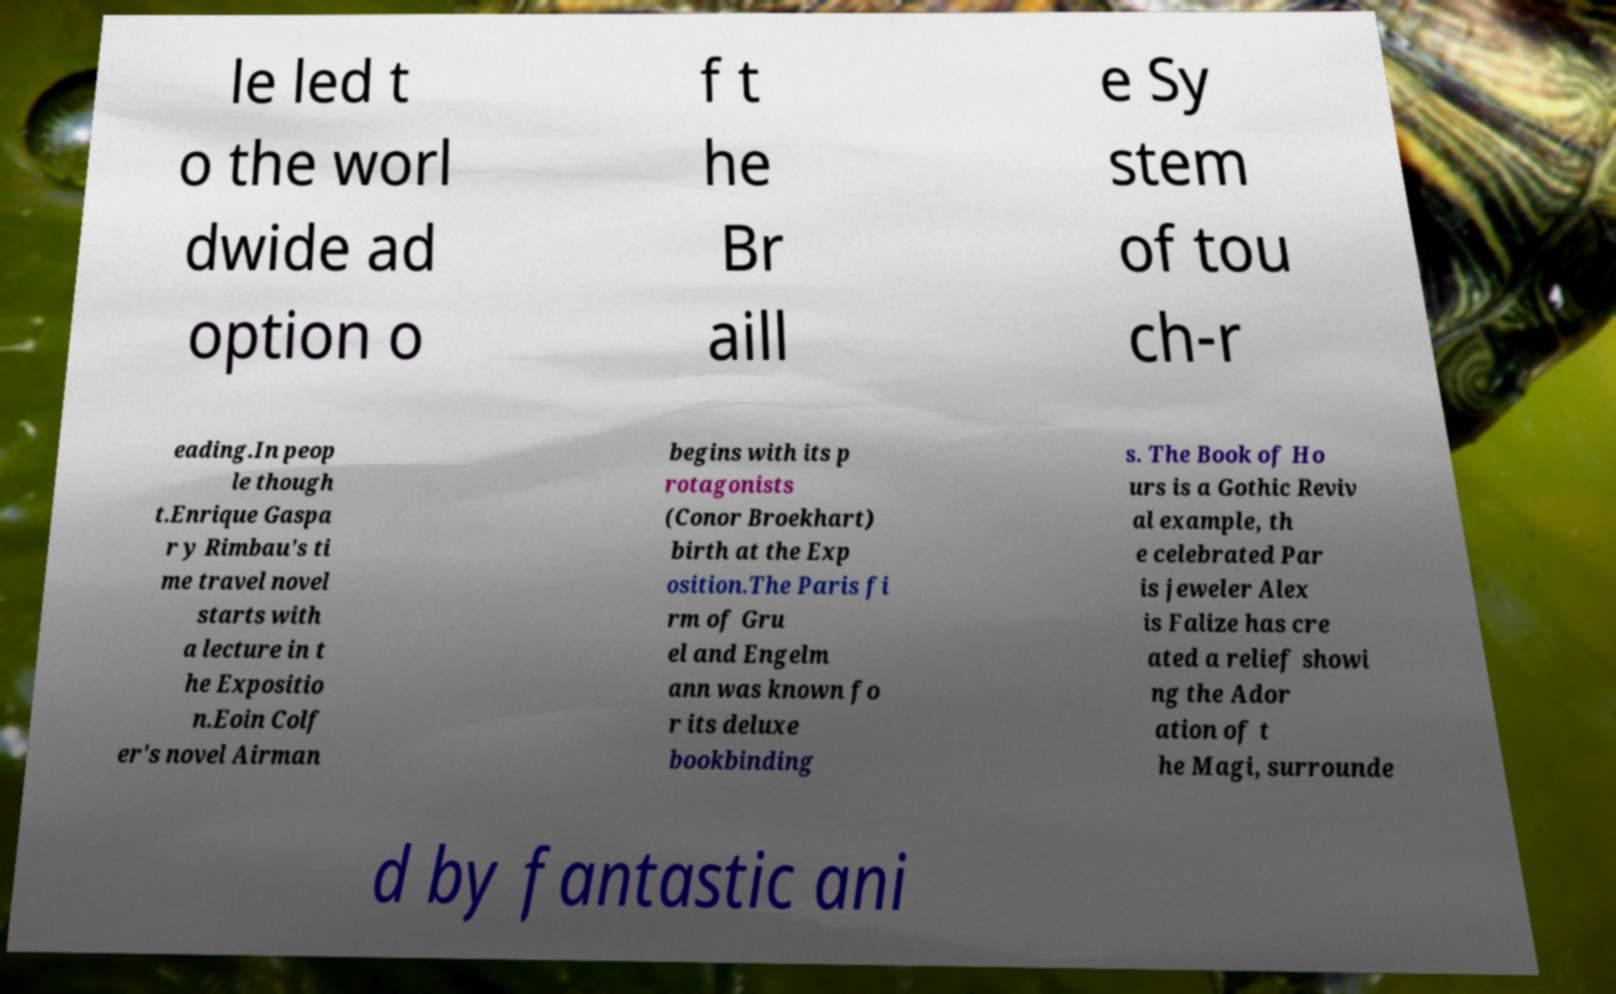What messages or text are displayed in this image? I need them in a readable, typed format. le led t o the worl dwide ad option o f t he Br aill e Sy stem of tou ch-r eading.In peop le though t.Enrique Gaspa r y Rimbau's ti me travel novel starts with a lecture in t he Expositio n.Eoin Colf er's novel Airman begins with its p rotagonists (Conor Broekhart) birth at the Exp osition.The Paris fi rm of Gru el and Engelm ann was known fo r its deluxe bookbinding s. The Book of Ho urs is a Gothic Reviv al example, th e celebrated Par is jeweler Alex is Falize has cre ated a relief showi ng the Ador ation of t he Magi, surrounde d by fantastic ani 